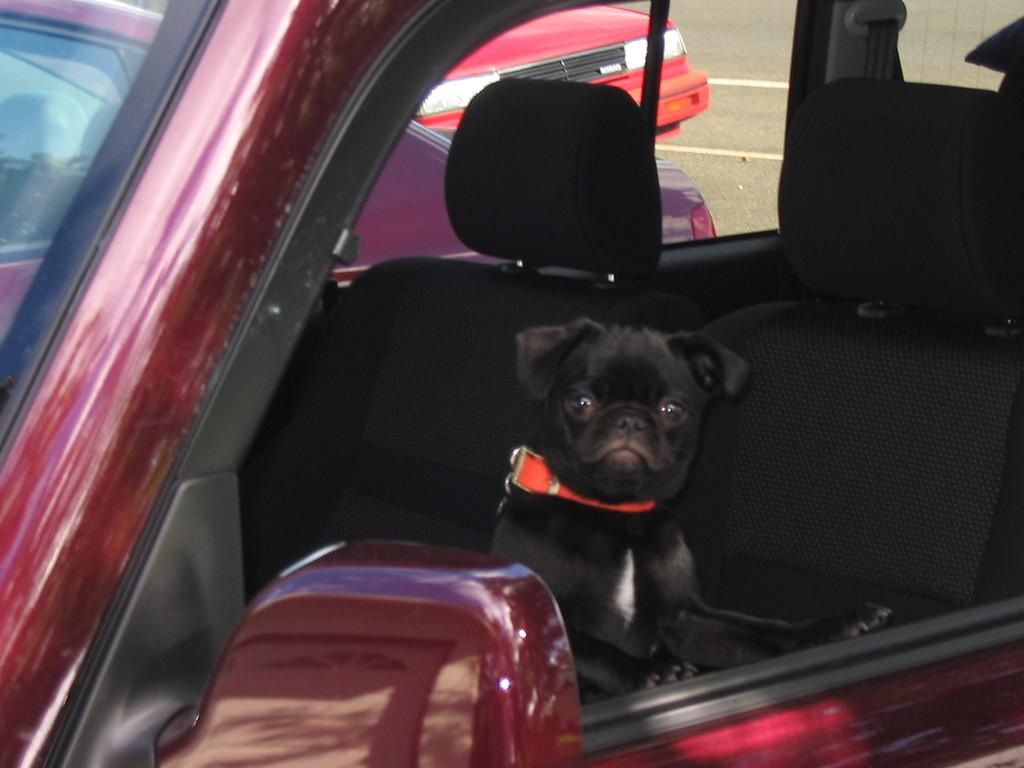What is the main subject of the image? There is a car in the image. Are there any animals present in the car? Yes, there is a black color dog inside the car. What can be seen through the car's window? Two other cars are visible through the car's window. How many kisses does the dog give to the end of the wish in the image? There is no mention of kisses, the end, or a wish in the image. The image only features a car with a dog inside and two other cars visible through the window. 